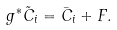Convert formula to latex. <formula><loc_0><loc_0><loc_500><loc_500>g ^ { \ast } \tilde { C } _ { i } = \bar { C } _ { i } + F .</formula> 